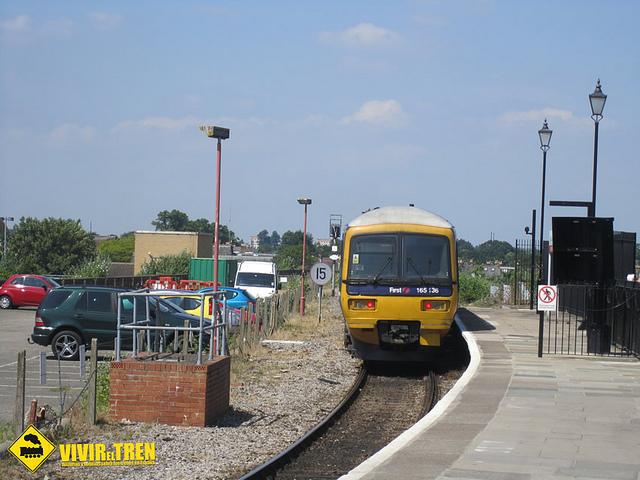Is someone driving the train?
Keep it brief. Yes. What color is the train?
Short answer required. Yellow. Is the train still in use?
Write a very short answer. Yes. How many light post?
Be succinct. 2. 